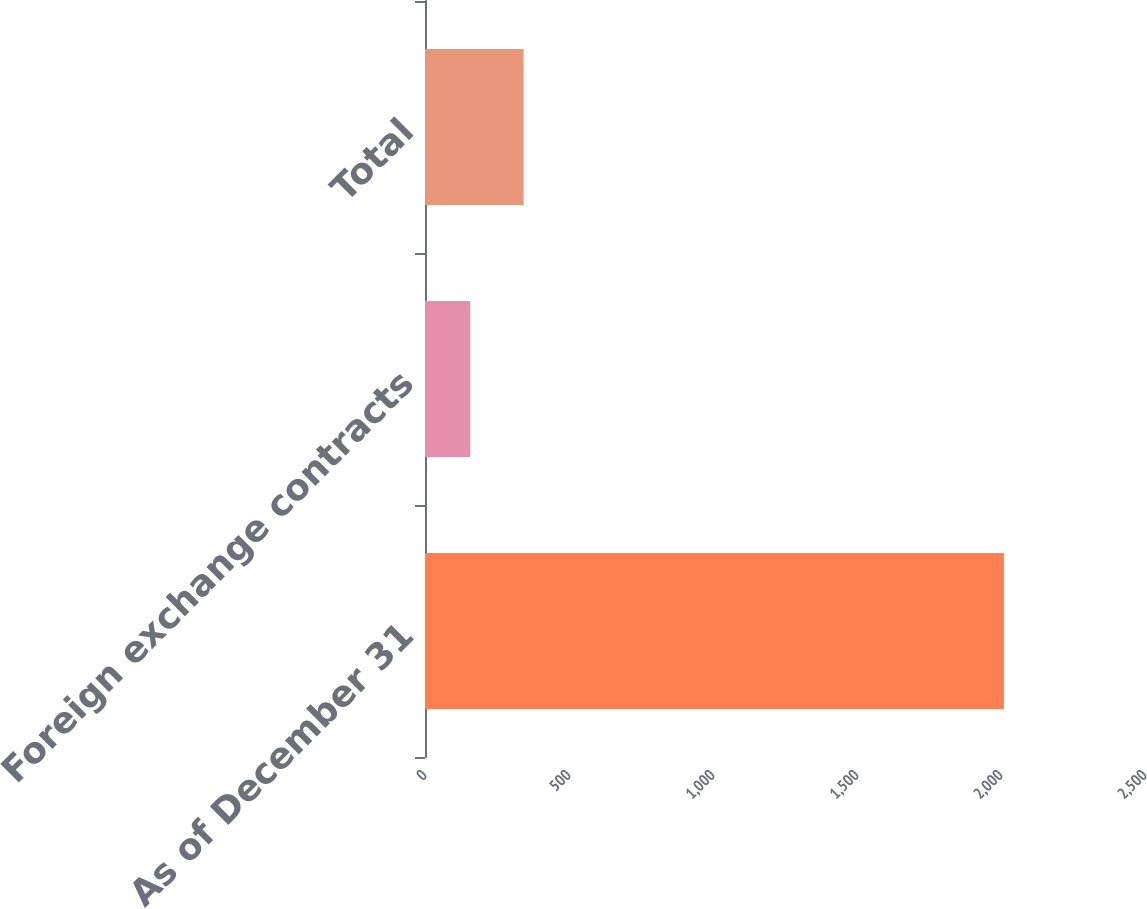Convert chart to OTSL. <chart><loc_0><loc_0><loc_500><loc_500><bar_chart><fcel>As of December 31<fcel>Foreign exchange contracts<fcel>Total<nl><fcel>2010<fcel>157<fcel>342.3<nl></chart> 